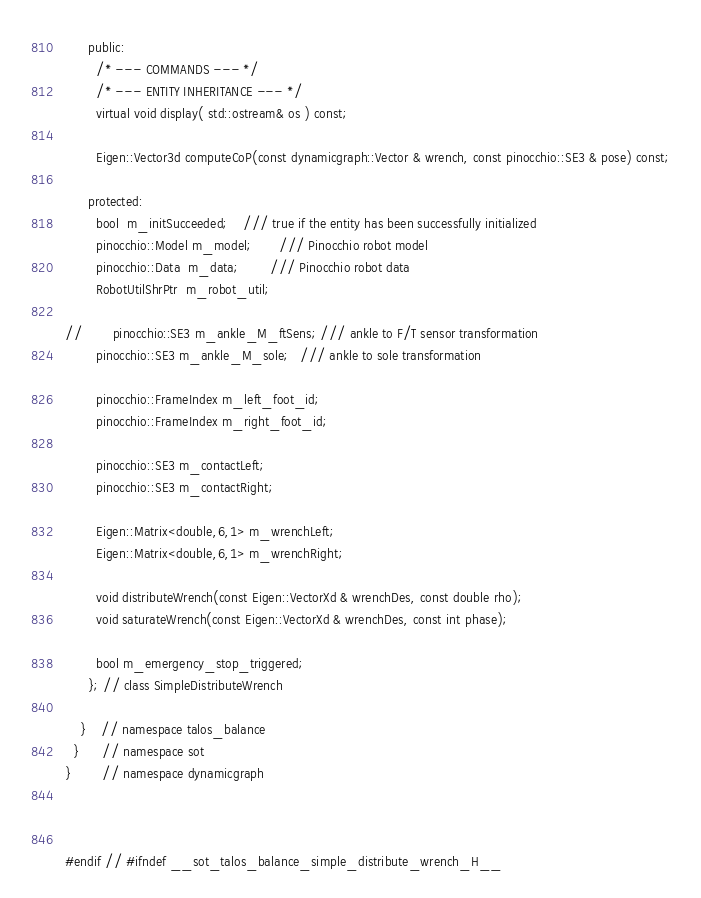<code> <loc_0><loc_0><loc_500><loc_500><_C++_>      public:
        /* --- COMMANDS --- */
        /* --- ENTITY INHERITANCE --- */
        virtual void display( std::ostream& os ) const;

        Eigen::Vector3d computeCoP(const dynamicgraph::Vector & wrench, const pinocchio::SE3 & pose) const;

      protected:
        bool  m_initSucceeded;    /// true if the entity has been successfully initialized
        pinocchio::Model m_model;       /// Pinocchio robot model
        pinocchio::Data  m_data;        /// Pinocchio robot data
        RobotUtilShrPtr  m_robot_util;

//        pinocchio::SE3 m_ankle_M_ftSens; /// ankle to F/T sensor transformation
        pinocchio::SE3 m_ankle_M_sole;   /// ankle to sole transformation

        pinocchio::FrameIndex m_left_foot_id;
        pinocchio::FrameIndex m_right_foot_id;

        pinocchio::SE3 m_contactLeft;
        pinocchio::SE3 m_contactRight;

        Eigen::Matrix<double,6,1> m_wrenchLeft;
        Eigen::Matrix<double,6,1> m_wrenchRight;

        void distributeWrench(const Eigen::VectorXd & wrenchDes, const double rho);
        void saturateWrench(const Eigen::VectorXd & wrenchDes, const int phase);

        bool m_emergency_stop_triggered;
      }; // class SimpleDistributeWrench

    }    // namespace talos_balance
  }      // namespace sot
}        // namespace dynamicgraph



#endif // #ifndef __sot_talos_balance_simple_distribute_wrench_H__
</code> 